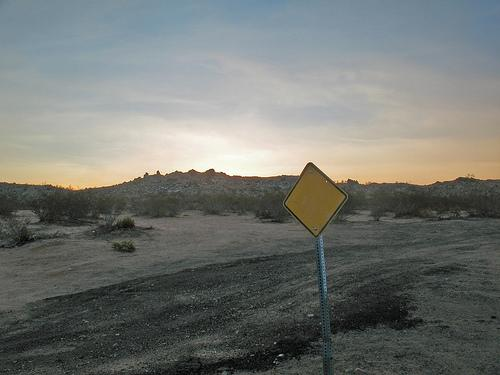What are the main colors present in the image? The dominant colors in the image are yellow, black, blue, green, brown, and grey. List three key objects in the image, and mention their colors. There is a yellow sign with black trim, a silver metal pole, and a blue sky with white clouds. Describe the atmosphere and general feeling conveyed by the image. The scene evokes a sense of peacefulness, with a quiet road surrounded by natural beauty and a serene sky. Summarize the scene in the image in a single sentence. A yellow and black signpost stands on a dirt road with lush nature and mountains in the background. Describe the different materials and textures found in the image. The image shows a metal sign and pole, bolts, gravel, dirt, and organic materials like plants and bushes. Mention the different types of vegetation seen in the image and their location. There are bushes behind the sign, several plants in the dirt, and a tree on a hill in the distance. Provide a brief description of the most prominent feature in the image. A black and yellow sign is mounted on a silver pole, leaning slightly to the left and held in place by two grey bolts. Provide a poetic description of the main subject in the image. A sign of yellow hue with a border of black, stands firm on a pole, amidst nature's scenic backdrop. Describe the ground and the surrounding area in the image. The ground consists of dirt and gravel on a road with some plants, disturbed dirt, and a signpost nearby. Mention the natural elements found in the background of the image. There are mountain ranges, forests, bushes, and a blue sky with clouds behind the signpost. 